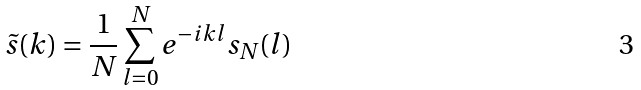Convert formula to latex. <formula><loc_0><loc_0><loc_500><loc_500>\tilde { s } ( k ) = \frac { 1 } { N } \sum _ { l = 0 } ^ { N } e ^ { - i k l } s _ { N } ( l )</formula> 